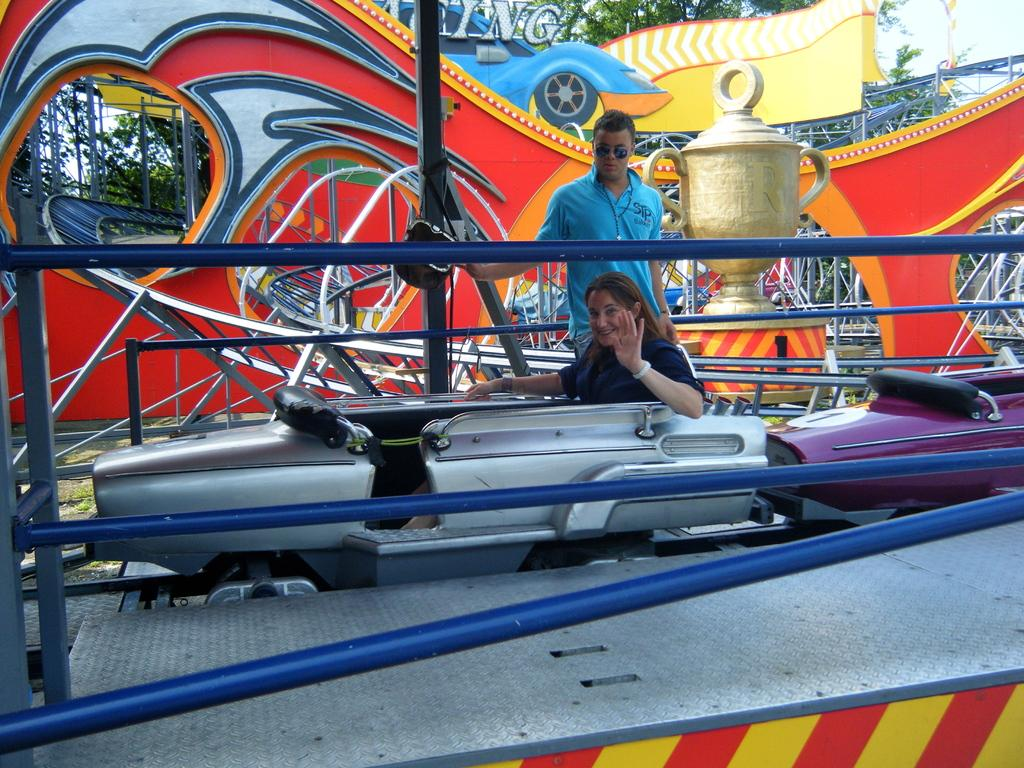What is the main subject of the image? There is a man standing in the image. What is the man wearing in the image? The man is wearing sunglasses. Are there any other people in the image? Yes, there are other people wearing sunglasses. What is the position of the woman in the image? The woman is seated in the image. What type of natural environment is visible in the image? Trees are visible in the image. How would you describe the weather based on the image? The sky is cloudy in the image, suggesting overcast or potentially rainy weather. What type of mark can be seen on the sidewalk in the image? There is no sidewalk present in the image, so it is not possible to determine if there is a mark on it. 